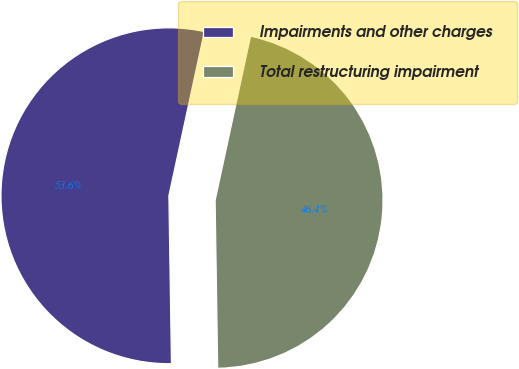Convert chart. <chart><loc_0><loc_0><loc_500><loc_500><pie_chart><fcel>Impairments and other charges<fcel>Total restructuring impairment<nl><fcel>53.63%<fcel>46.37%<nl></chart> 